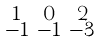<formula> <loc_0><loc_0><loc_500><loc_500>\begin{smallmatrix} 1 & 0 & 2 \\ - 1 & - 1 & - 3 \end{smallmatrix}</formula> 